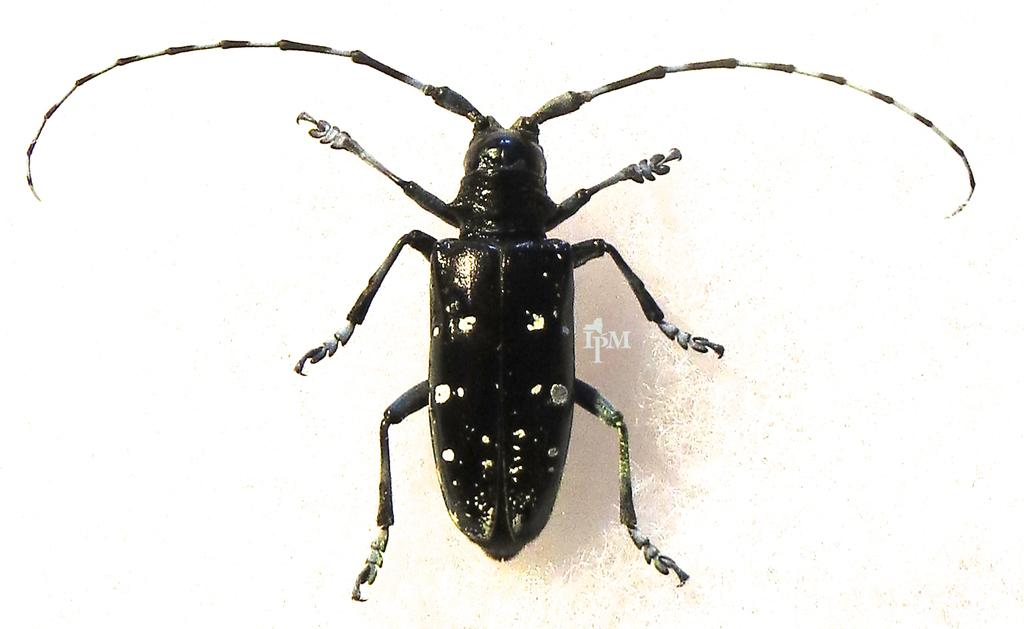What is the main subject in the center of the image? There is an insect and some text in the center of the image. Can you describe the insect in the image? Unfortunately, the facts provided do not give any details about the insect's appearance or type. What does the text in the center of the image say? The facts provided do not give any information about the content of the text. What type of feather is being used as a cannon in the image? There is no feather or cannon present in the image. What scene is depicted in the image? The facts provided do not give any information about a scene or any other context beyond the insect and the text in the center of the image. 